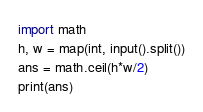<code> <loc_0><loc_0><loc_500><loc_500><_Python_>import math
h, w = map(int, input().split())
ans = math.ceil(h*w/2)
print(ans)
</code> 